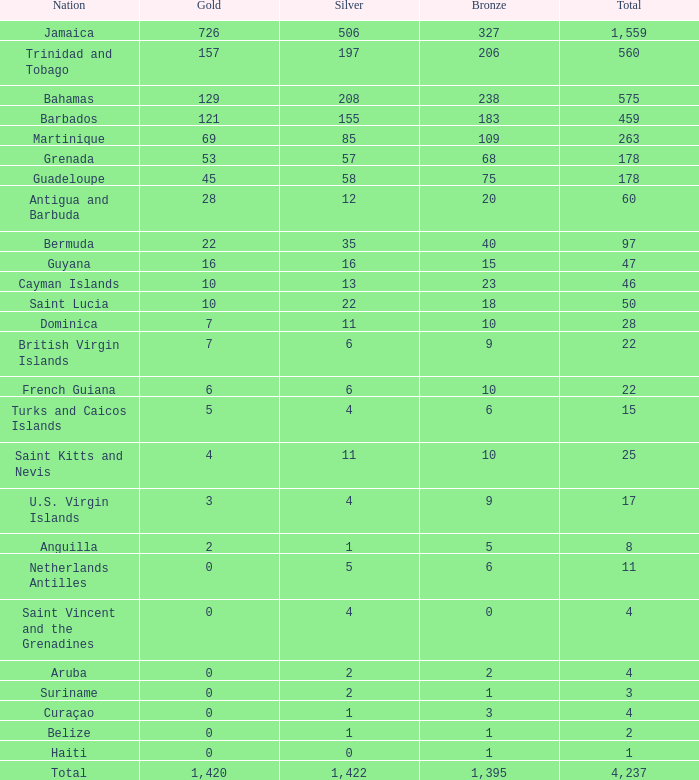What's the sum of Silver with total smaller than 560, a Bronze larger than 6, and a Gold of 3? 4.0. 